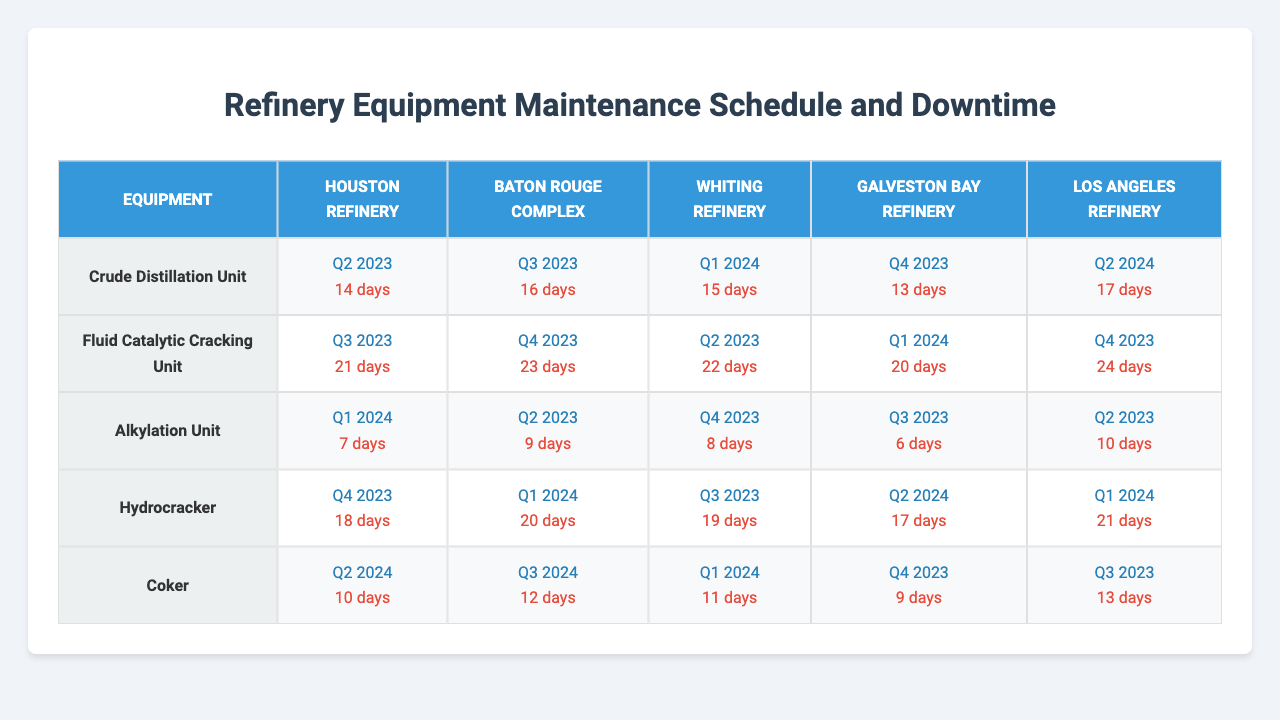What is the maintenance schedule for the Crude Distillation Unit at the Houston Refinery? The table indicates that the maintenance schedule for the Crude Distillation Unit at the Houston Refinery is "Q2 2023."
Answer: Q2 2023 How many days of downtime is expected for the Hydrocracker at the Los Angeles Refinery? According to the table, the downtime for the Hydrocracker at the Los Angeles Refinery is 21 days.
Answer: 21 days Which refinery has the longest downtime for the Fluid Catalytic Cracking Unit? The table shows that the Los Angeles Refinery has the longest downtime at 24 days for the Fluid Catalytic Cracking Unit.
Answer: Los Angeles Refinery What is the total downtime for the Crude Distillation Unit across all refineries? The downtimes for the Crude Distillation Unit are: Houston (14), Baton Rouge (16), Whiting (15), Galveston Bay (13), and Los Angeles (17). The total is 14 + 16 + 15 + 13 + 17 = 75 days.
Answer: 75 days Is the Coker in the Whiting Refinery scheduled for maintenance before the one in the Baton Rouge Complex? The Coker in the Whiting Refinery is scheduled for Q1 2024, while the Coker in the Baton Rouge Complex is scheduled for Q3 2024, meaning the Whiting's maintenance is scheduled earlier.
Answer: Yes What is the average downtime for the Alkylation Unit across all refineries? The downtimes for the Alkylation Unit are: Houston (7), Baton Rouge (9), Whiting (8), Galveston Bay (6), and Los Angeles (10). The average is calculated as (7 + 9 + 8 + 6 + 10) / 5 = 8 days.
Answer: 8 days Which unit in the Baton Rouge Complex has the highest downtime, and what is the value? The Fluid Catalytic Cracking Unit has the highest downtime in the Baton Rouge Complex at 23 days, according to the table.
Answer: Fluid Catalytic Cracking Unit, 23 days What is the difference in downtime for the Hydrocracker between the Houston and Galveston Bay refineries? The Hydrocracker downtime for Houston is 18 days and for Galveston Bay is 17 days, resulting in a difference of 18 - 17 = 1 day.
Answer: 1 day Which refinery has scheduled maintenance for the Alkylation Unit the earliest? The Baton Rouge Complex has its Alkylation Unit scheduled for maintenance in Q2 2023, which is the earliest compared to the other refineries.
Answer: Baton Rouge Complex How many total days of downtime does the Coker have across all refineries? The downtimes for the Coker are: Houston (10), Baton Rouge (12), Whiting (11), Galveston Bay (9), and Los Angeles (13). Summing these gives a total of 10 + 12 + 11 + 9 + 13 = 55 days.
Answer: 55 days 